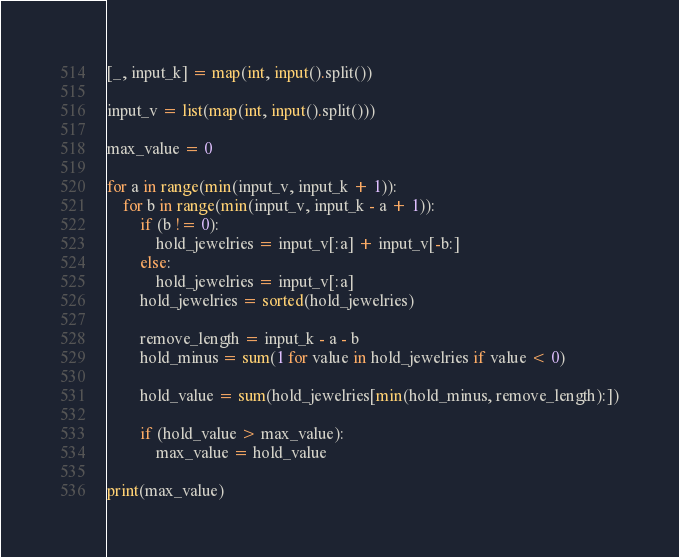Convert code to text. <code><loc_0><loc_0><loc_500><loc_500><_Python_>[_, input_k] = map(int, input().split())

input_v = list(map(int, input().split()))

max_value = 0

for a in range(min(input_v, input_k + 1)):
    for b in range(min(input_v, input_k - a + 1)):
        if (b != 0):
            hold_jewelries = input_v[:a] + input_v[-b:]
        else:
            hold_jewelries = input_v[:a]
        hold_jewelries = sorted(hold_jewelries)

        remove_length = input_k - a - b 
        hold_minus = sum(1 for value in hold_jewelries if value < 0)

        hold_value = sum(hold_jewelries[min(hold_minus, remove_length):])

        if (hold_value > max_value):
            max_value = hold_value

print(max_value)
</code> 